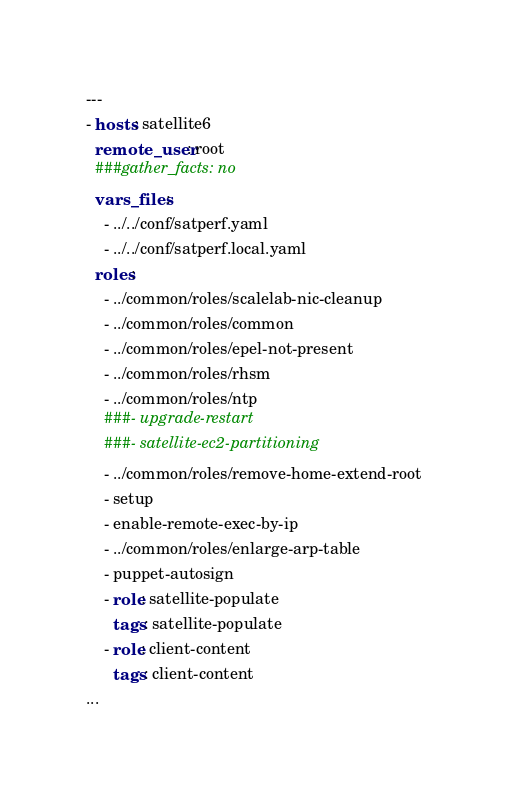Convert code to text. <code><loc_0><loc_0><loc_500><loc_500><_YAML_>---
- hosts: satellite6
  remote_user: root
  ###gather_facts: no
  vars_files:
    - ../../conf/satperf.yaml
    - ../../conf/satperf.local.yaml
  roles:
    - ../common/roles/scalelab-nic-cleanup
    - ../common/roles/common
    - ../common/roles/epel-not-present
    - ../common/roles/rhsm
    - ../common/roles/ntp
    ###- upgrade-restart
    ###- satellite-ec2-partitioning
    - ../common/roles/remove-home-extend-root
    - setup
    - enable-remote-exec-by-ip
    - ../common/roles/enlarge-arp-table
    - puppet-autosign
    - role: satellite-populate
      tags: satellite-populate
    - role: client-content
      tags: client-content
...
</code> 